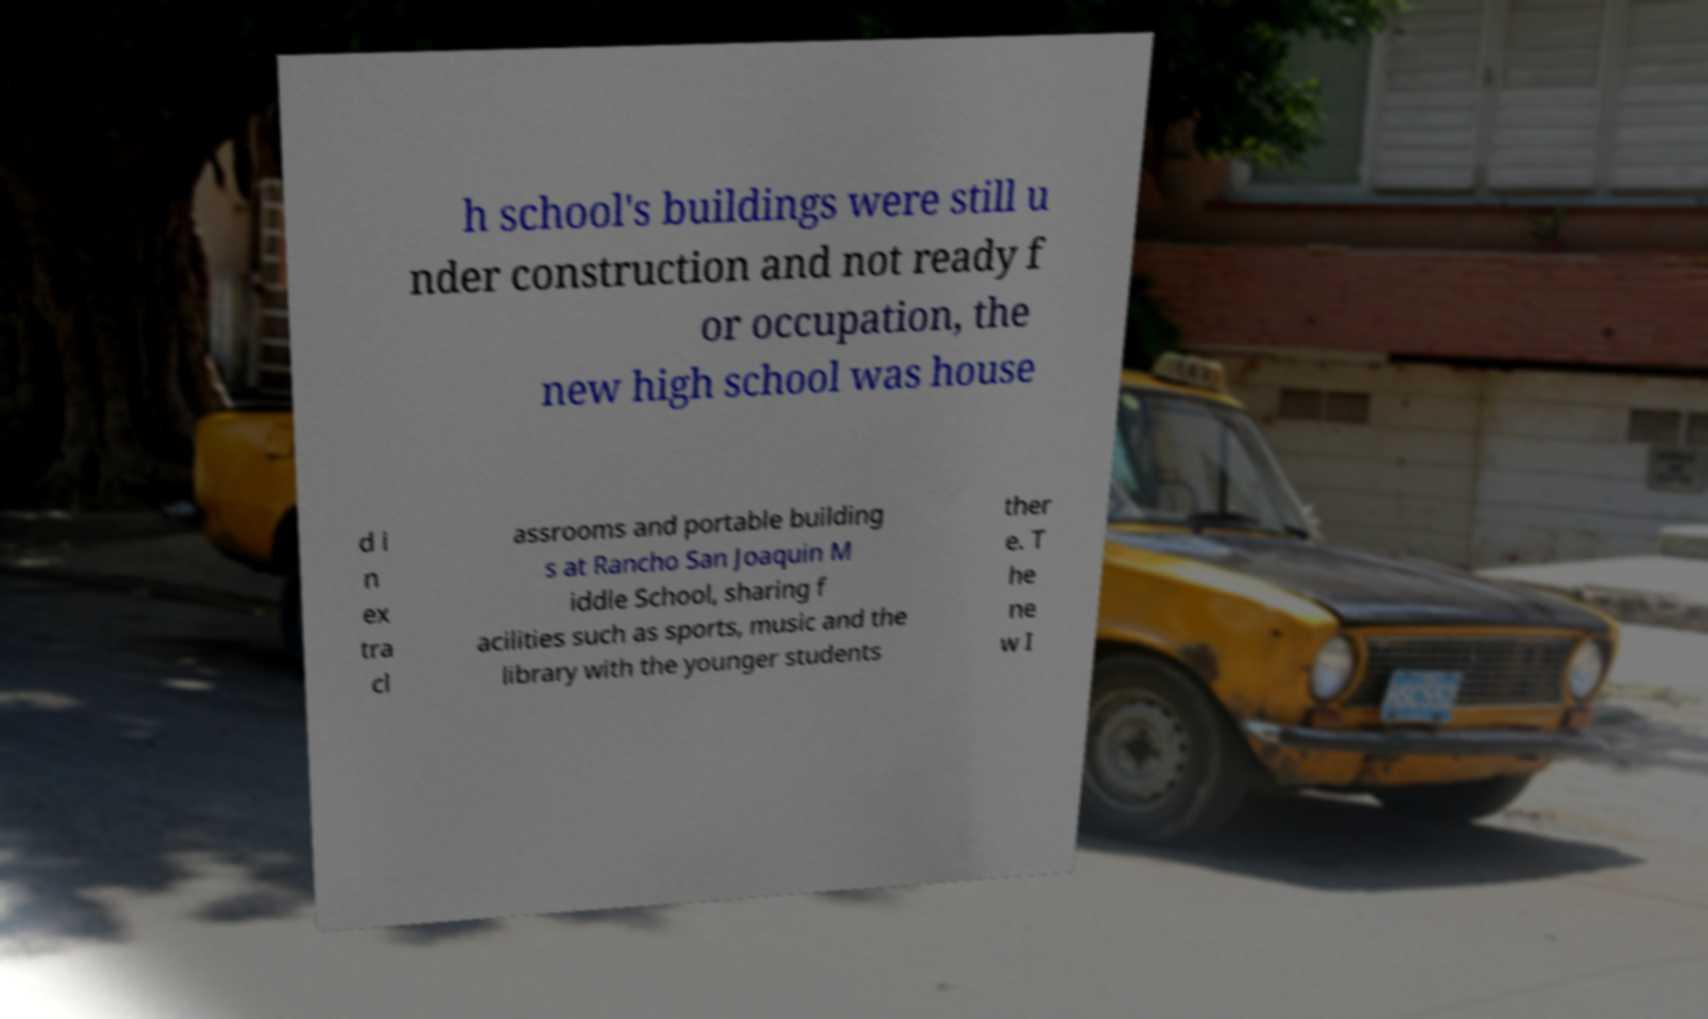I need the written content from this picture converted into text. Can you do that? h school's buildings were still u nder construction and not ready f or occupation, the new high school was house d i n ex tra cl assrooms and portable building s at Rancho San Joaquin M iddle School, sharing f acilities such as sports, music and the library with the younger students ther e. T he ne w I 